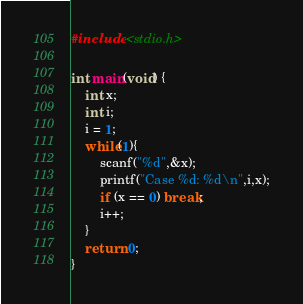Convert code to text. <code><loc_0><loc_0><loc_500><loc_500><_C_>#include <stdio.h>

int main(void) {
	int x;
	int i;
	i = 1;
	while(1){
		scanf("%d",&x);
		printf("Case %d: %d\n",i,x);
		if (x == 0) break;
		i++;
	}
	return 0;
}
</code> 